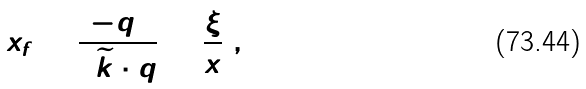Convert formula to latex. <formula><loc_0><loc_0><loc_500><loc_500>x _ { f } = \frac { - q ^ { 2 } } { 2 \widetilde { k } \cdot q } = \frac { \xi } { x } \ ,</formula> 